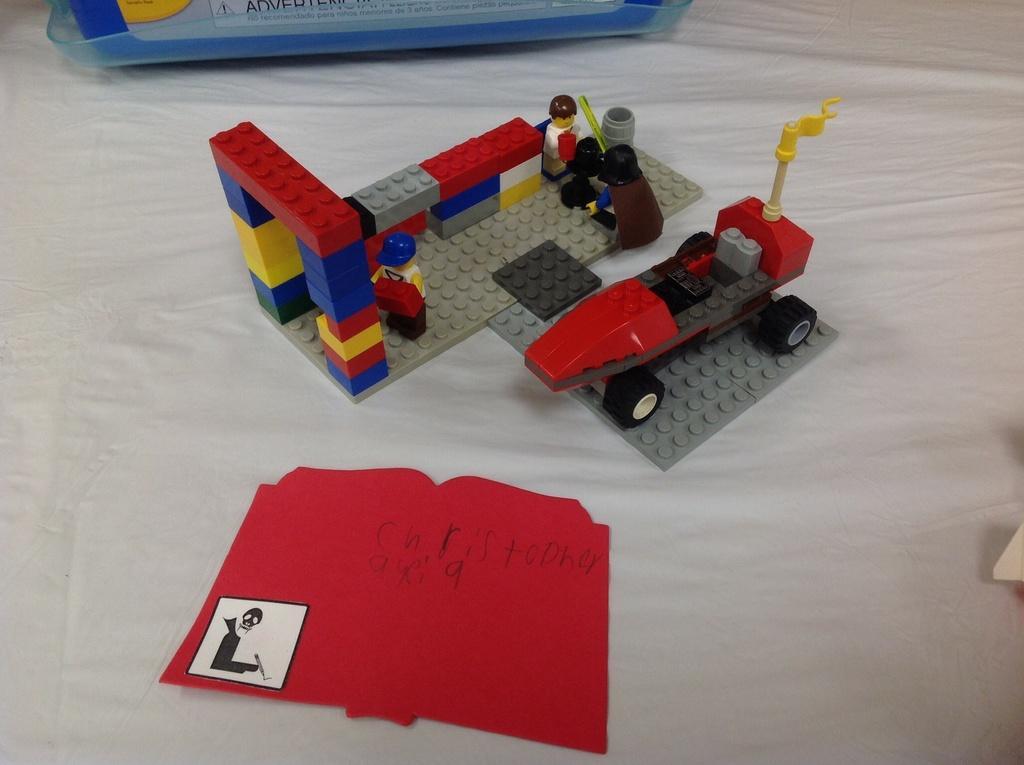Describe this image in one or two sentences. In the middle of the image there are few toys and there is a book with a text and an image on the surface. In the background there is an object. At the bottom of the image there is a cloth which is white in color. 